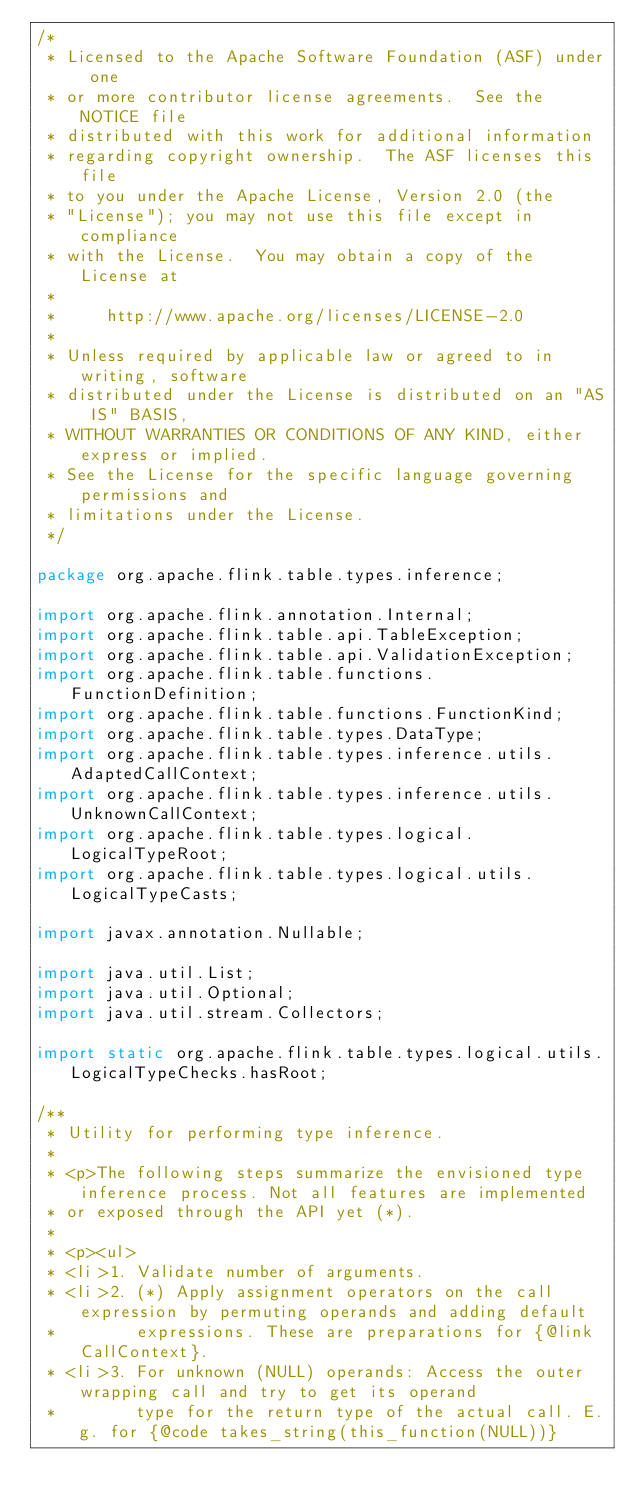<code> <loc_0><loc_0><loc_500><loc_500><_Java_>/*
 * Licensed to the Apache Software Foundation (ASF) under one
 * or more contributor license agreements.  See the NOTICE file
 * distributed with this work for additional information
 * regarding copyright ownership.  The ASF licenses this file
 * to you under the Apache License, Version 2.0 (the
 * "License"); you may not use this file except in compliance
 * with the License.  You may obtain a copy of the License at
 *
 *     http://www.apache.org/licenses/LICENSE-2.0
 *
 * Unless required by applicable law or agreed to in writing, software
 * distributed under the License is distributed on an "AS IS" BASIS,
 * WITHOUT WARRANTIES OR CONDITIONS OF ANY KIND, either express or implied.
 * See the License for the specific language governing permissions and
 * limitations under the License.
 */

package org.apache.flink.table.types.inference;

import org.apache.flink.annotation.Internal;
import org.apache.flink.table.api.TableException;
import org.apache.flink.table.api.ValidationException;
import org.apache.flink.table.functions.FunctionDefinition;
import org.apache.flink.table.functions.FunctionKind;
import org.apache.flink.table.types.DataType;
import org.apache.flink.table.types.inference.utils.AdaptedCallContext;
import org.apache.flink.table.types.inference.utils.UnknownCallContext;
import org.apache.flink.table.types.logical.LogicalTypeRoot;
import org.apache.flink.table.types.logical.utils.LogicalTypeCasts;

import javax.annotation.Nullable;

import java.util.List;
import java.util.Optional;
import java.util.stream.Collectors;

import static org.apache.flink.table.types.logical.utils.LogicalTypeChecks.hasRoot;

/**
 * Utility for performing type inference.
 *
 * <p>The following steps summarize the envisioned type inference process. Not all features are implemented
 * or exposed through the API yet (*).
 *
 * <p><ul>
 * <li>1. Validate number of arguments.
 * <li>2. (*) Apply assignment operators on the call expression by permuting operands and adding default
 *        expressions. These are preparations for {@link CallContext}.
 * <li>3. For unknown (NULL) operands: Access the outer wrapping call and try to get its operand
 *        type for the return type of the actual call. E.g. for {@code takes_string(this_function(NULL))}</code> 